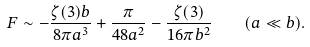<formula> <loc_0><loc_0><loc_500><loc_500>F \sim - \frac { \zeta ( 3 ) b } { 8 \pi a ^ { 3 } } + \frac { \pi } { 4 8 a ^ { 2 } } - \frac { \zeta ( 3 ) } { 1 6 \pi b ^ { 2 } } \quad ( a \ll b ) .</formula> 